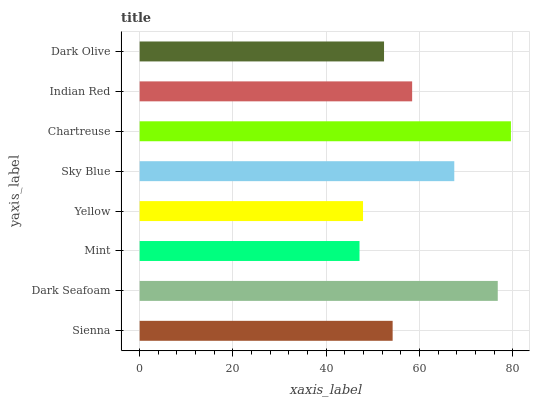Is Mint the minimum?
Answer yes or no. Yes. Is Chartreuse the maximum?
Answer yes or no. Yes. Is Dark Seafoam the minimum?
Answer yes or no. No. Is Dark Seafoam the maximum?
Answer yes or no. No. Is Dark Seafoam greater than Sienna?
Answer yes or no. Yes. Is Sienna less than Dark Seafoam?
Answer yes or no. Yes. Is Sienna greater than Dark Seafoam?
Answer yes or no. No. Is Dark Seafoam less than Sienna?
Answer yes or no. No. Is Indian Red the high median?
Answer yes or no. Yes. Is Sienna the low median?
Answer yes or no. Yes. Is Dark Olive the high median?
Answer yes or no. No. Is Yellow the low median?
Answer yes or no. No. 